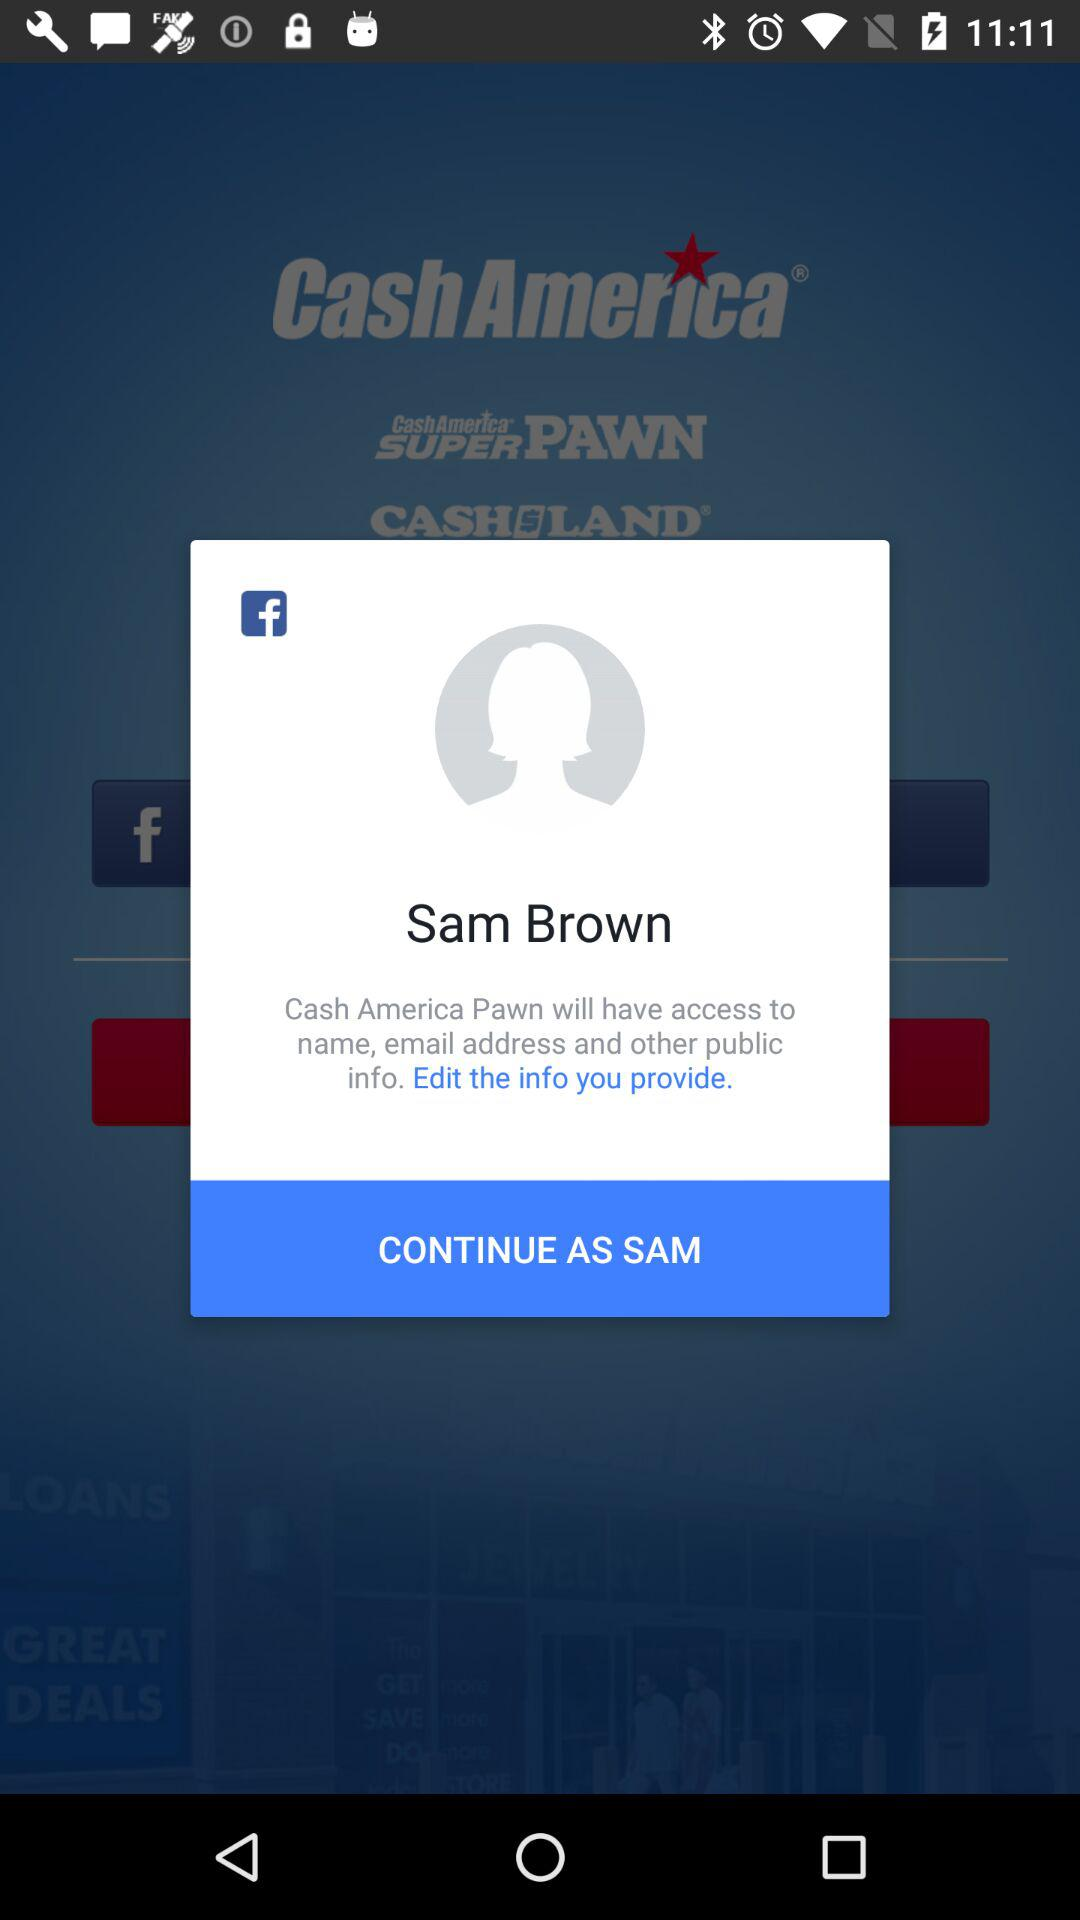How old is Sam Brown?
When the provided information is insufficient, respond with <no answer>. <no answer> 